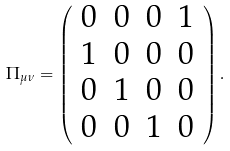<formula> <loc_0><loc_0><loc_500><loc_500>\Pi _ { \mu \nu } = \left ( \begin{array} { c c c c } 0 & 0 & 0 & 1 \\ 1 & 0 & 0 & 0 \\ 0 & 1 & 0 & 0 \\ 0 & 0 & 1 & 0 \end{array} \right ) .</formula> 